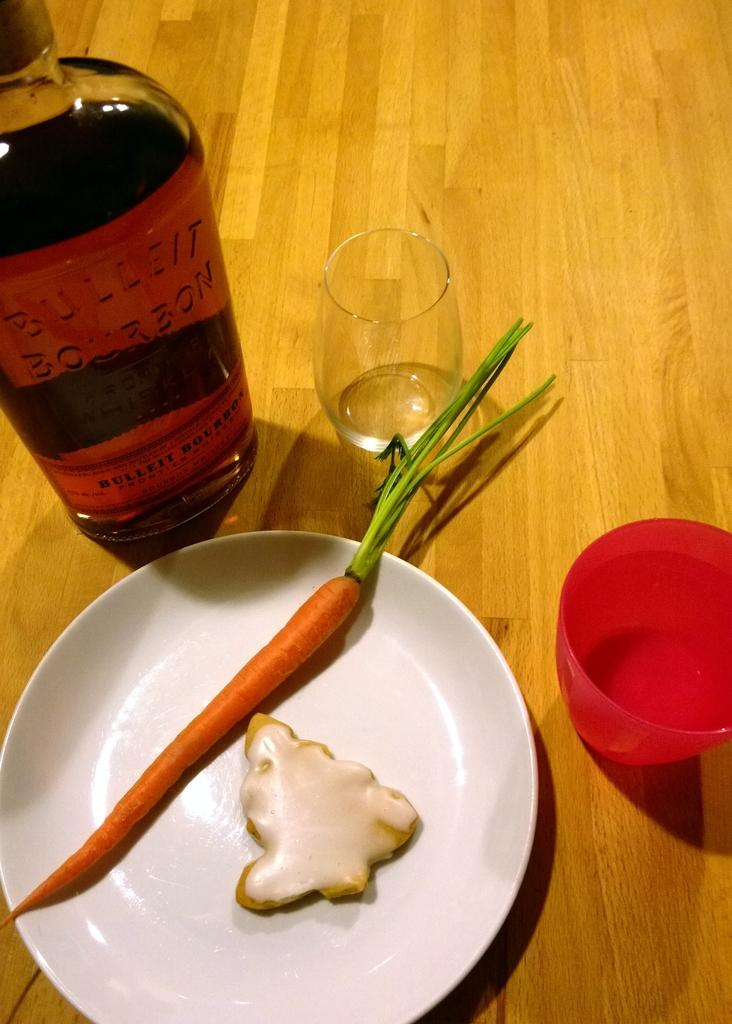<image>
Offer a succinct explanation of the picture presented. A bottle of bulleit bourbon along with a single carrot and cookie on a plate. 